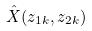<formula> <loc_0><loc_0><loc_500><loc_500>\hat { X } ( z _ { 1 k } , z _ { 2 k } )</formula> 